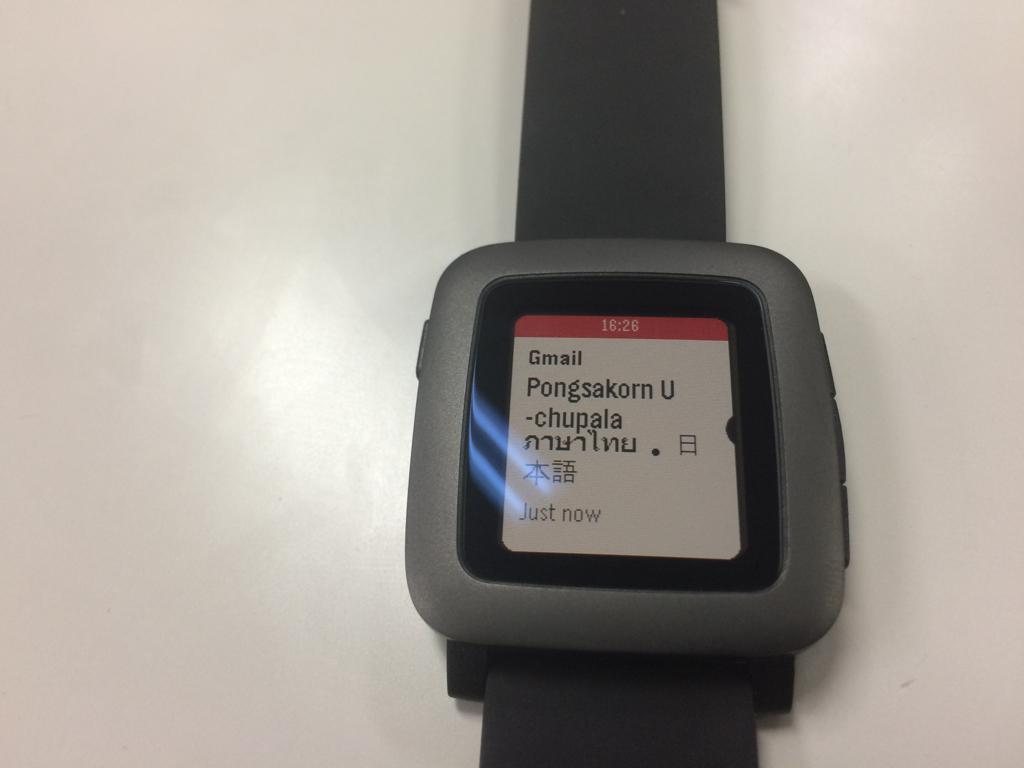<image>
Create a compact narrative representing the image presented. Face of a watch which has the time at 16:26. 